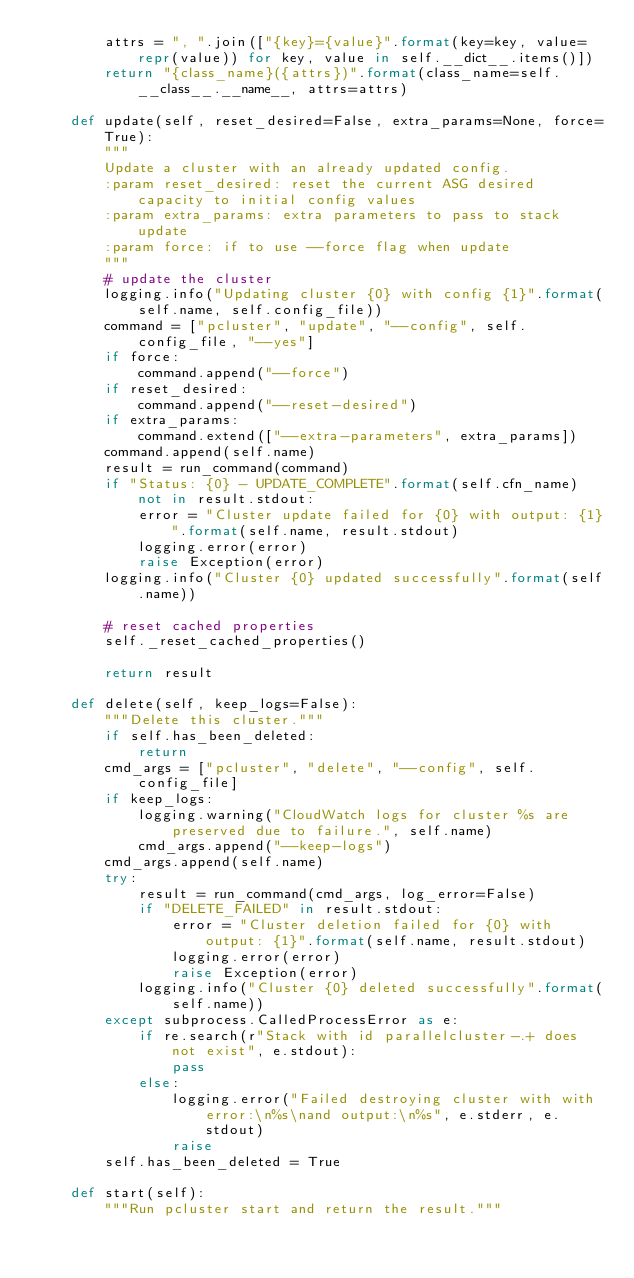<code> <loc_0><loc_0><loc_500><loc_500><_Python_>        attrs = ", ".join(["{key}={value}".format(key=key, value=repr(value)) for key, value in self.__dict__.items()])
        return "{class_name}({attrs})".format(class_name=self.__class__.__name__, attrs=attrs)

    def update(self, reset_desired=False, extra_params=None, force=True):
        """
        Update a cluster with an already updated config.
        :param reset_desired: reset the current ASG desired capacity to initial config values
        :param extra_params: extra parameters to pass to stack update
        :param force: if to use --force flag when update
        """
        # update the cluster
        logging.info("Updating cluster {0} with config {1}".format(self.name, self.config_file))
        command = ["pcluster", "update", "--config", self.config_file, "--yes"]
        if force:
            command.append("--force")
        if reset_desired:
            command.append("--reset-desired")
        if extra_params:
            command.extend(["--extra-parameters", extra_params])
        command.append(self.name)
        result = run_command(command)
        if "Status: {0} - UPDATE_COMPLETE".format(self.cfn_name) not in result.stdout:
            error = "Cluster update failed for {0} with output: {1}".format(self.name, result.stdout)
            logging.error(error)
            raise Exception(error)
        logging.info("Cluster {0} updated successfully".format(self.name))

        # reset cached properties
        self._reset_cached_properties()

        return result

    def delete(self, keep_logs=False):
        """Delete this cluster."""
        if self.has_been_deleted:
            return
        cmd_args = ["pcluster", "delete", "--config", self.config_file]
        if keep_logs:
            logging.warning("CloudWatch logs for cluster %s are preserved due to failure.", self.name)
            cmd_args.append("--keep-logs")
        cmd_args.append(self.name)
        try:
            result = run_command(cmd_args, log_error=False)
            if "DELETE_FAILED" in result.stdout:
                error = "Cluster deletion failed for {0} with output: {1}".format(self.name, result.stdout)
                logging.error(error)
                raise Exception(error)
            logging.info("Cluster {0} deleted successfully".format(self.name))
        except subprocess.CalledProcessError as e:
            if re.search(r"Stack with id parallelcluster-.+ does not exist", e.stdout):
                pass
            else:
                logging.error("Failed destroying cluster with with error:\n%s\nand output:\n%s", e.stderr, e.stdout)
                raise
        self.has_been_deleted = True

    def start(self):
        """Run pcluster start and return the result."""</code> 